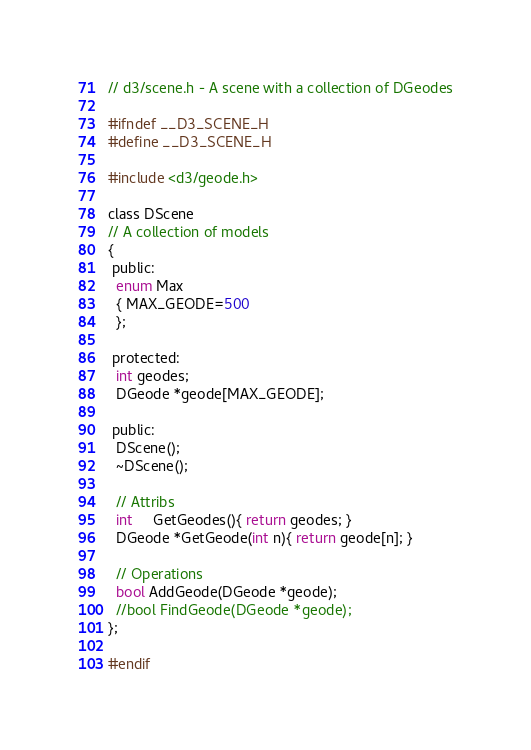Convert code to text. <code><loc_0><loc_0><loc_500><loc_500><_C_>// d3/scene.h - A scene with a collection of DGeodes

#ifndef __D3_SCENE_H
#define __D3_SCENE_H

#include <d3/geode.h>

class DScene
// A collection of models
{
 public:
  enum Max
  { MAX_GEODE=500
  };

 protected:
  int geodes;
  DGeode *geode[MAX_GEODE];

 public:
  DScene();
  ~DScene();

  // Attribs
  int     GetGeodes(){ return geodes; }
  DGeode *GetGeode(int n){ return geode[n]; }

  // Operations
  bool AddGeode(DGeode *geode);
  //bool FindGeode(DGeode *geode);
};

#endif
</code> 